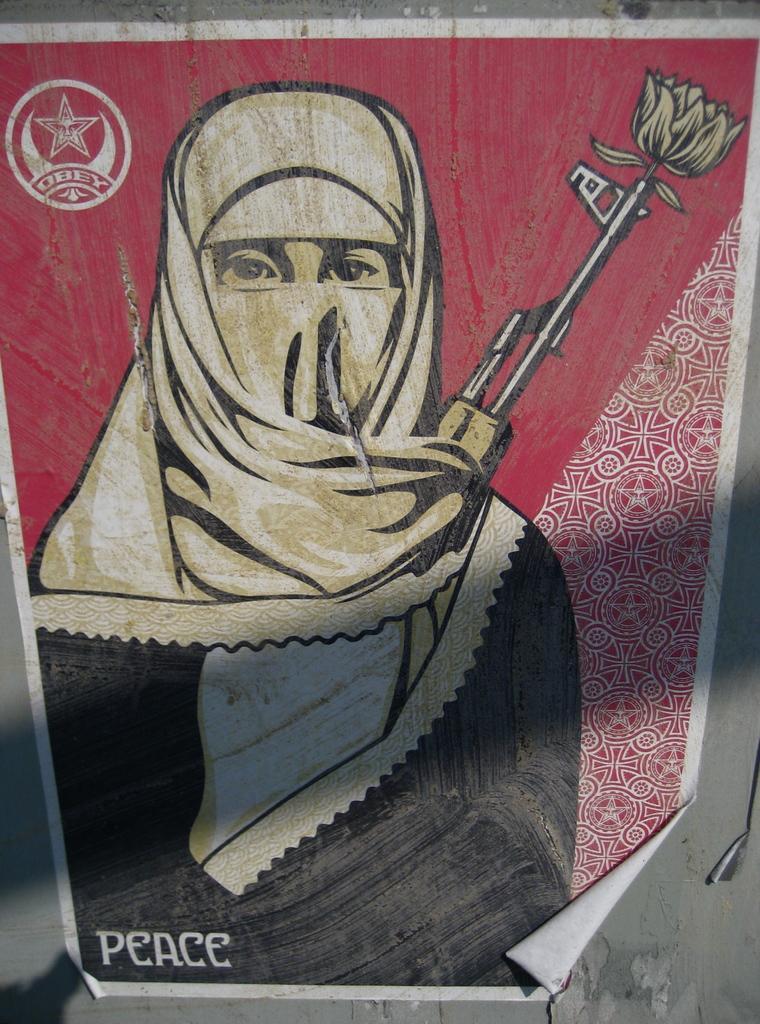Could you give a brief overview of what you see in this image? In this image there is a poster which is sticked to the wall. In the poster we can see there is a person who is wearing the mask. On the left side top corner there is a symbol. 